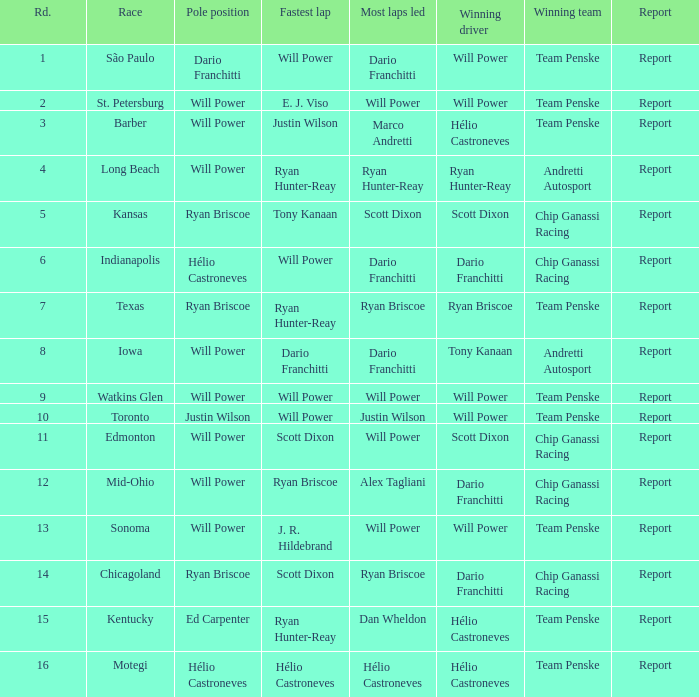Who was the pole-sitter at the chicagoland speedway? Ryan Briscoe. 